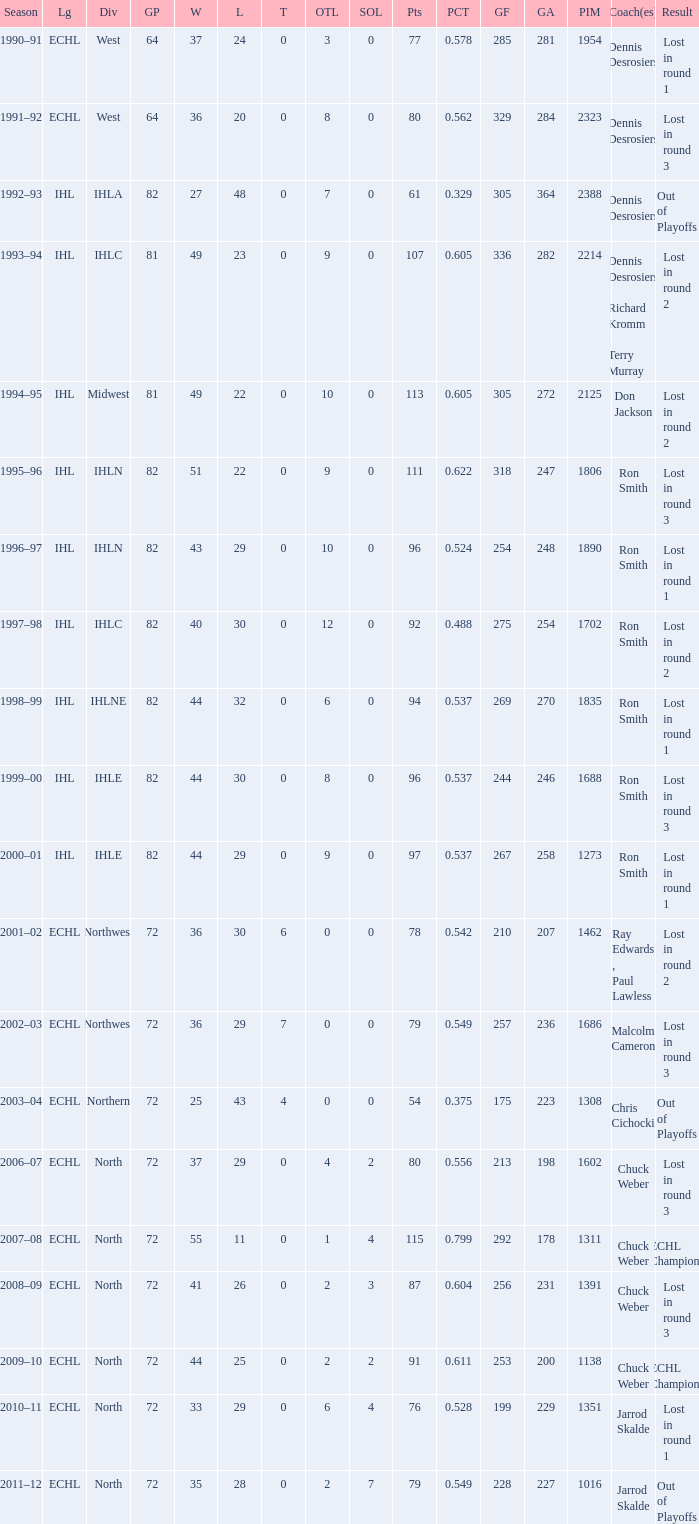What was the highest SOL where the team lost in round 3? 3.0. 